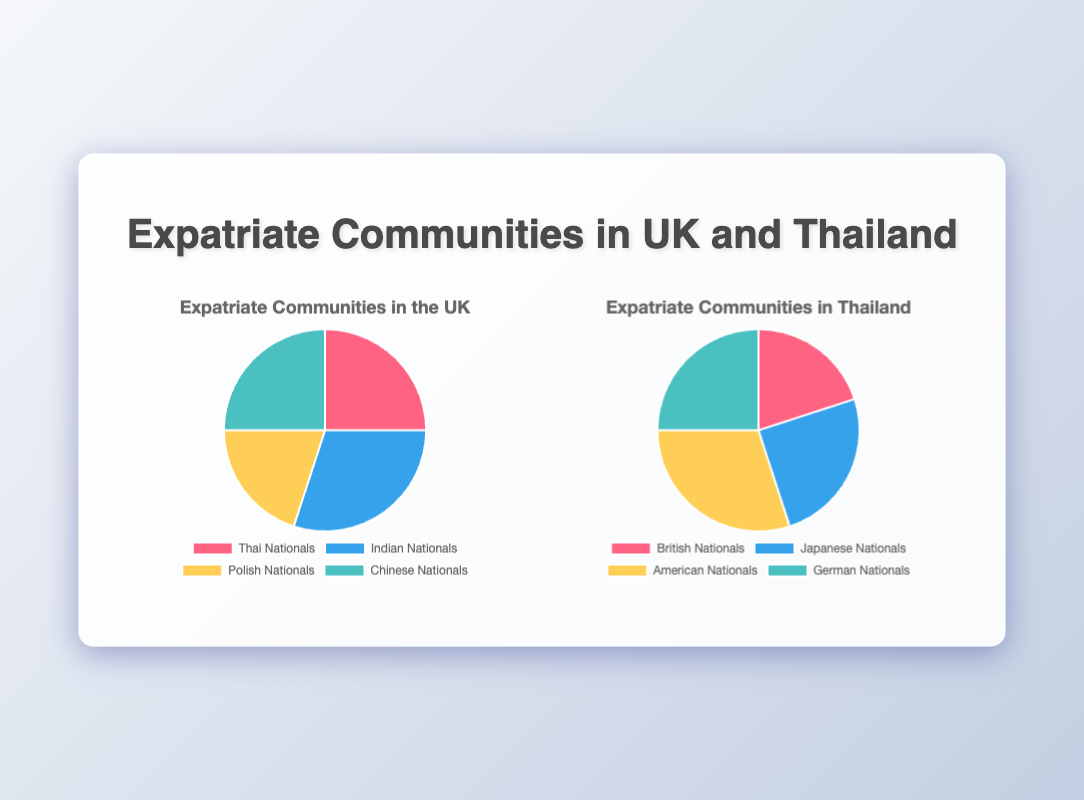Which expatriate community has the highest percentage in the UK? By looking at the pie chart for the UK, the Indian Nationals community appears to have the highest percentage, which is 30%.
Answer: Indian Nationals Which expatriate community has the lowest percentage in Thailand? By checking the pie chart for Thailand, the British Nationals community has the smallest percentage, which is 20%.
Answer: British Nationals How do the percentages of Thai Nationals and Chinese Nationals in the UK compare? According to the UK pie chart, both Thai Nationals and Chinese Nationals each make up 25% of the expatriate communities.
Answer: They are equal What's the total percentage of Indian Nationals and Polish Nationals in the UK? By adding the percentages of Indian Nationals (30%) and Polish Nationals (20%) from the UK pie chart, the total is 30% + 20% = 50%.
Answer: 50% What color represents American Nationals in the Thailand chart? Glancing at the Thailand pie chart, American Nationals are represented by yellow.
Answer: Yellow Which has a higher percentage in Thailand: British Nationals or German Nationals? From the Thailand pie chart, British Nationals are 20% and German Nationals are 25%. So, German Nationals have a higher percentage.
Answer: German Nationals What is the difference in percentage between Japanese Nationals and British Nationals in Thailand? In the Thailand pie chart, Japanese Nationals are 25% and British Nationals are 20%. The difference is 25% - 20% = 5%.
Answer: 5% Considering the UK and Thailand charts, which nationality appears in both but in different contexts? Examining both pie charts, Thai Nationals appear in the UK chart and British Nationals appear in the Thailand chart.
Answer: British and Thai Nationals 